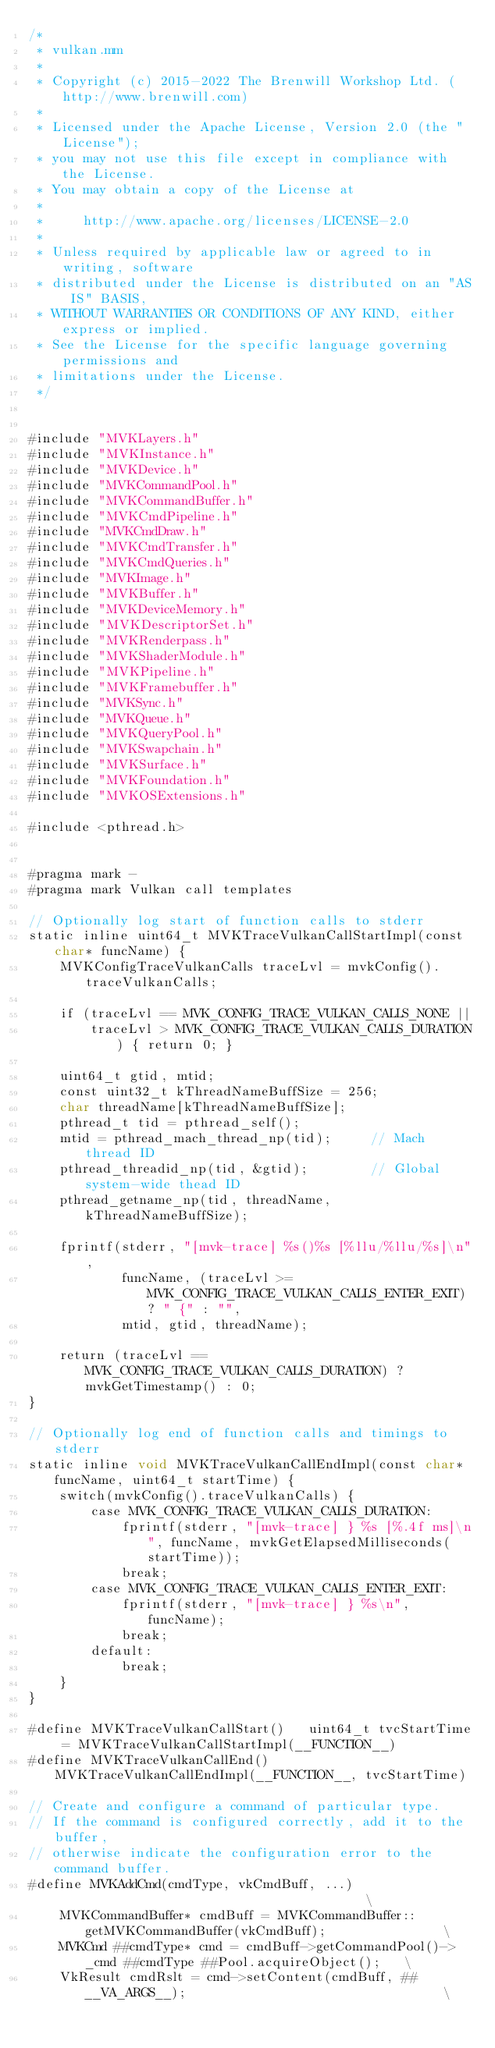<code> <loc_0><loc_0><loc_500><loc_500><_ObjectiveC_>/*
 * vulkan.mm
 *
 * Copyright (c) 2015-2022 The Brenwill Workshop Ltd. (http://www.brenwill.com)
 *
 * Licensed under the Apache License, Version 2.0 (the "License");
 * you may not use this file except in compliance with the License.
 * You may obtain a copy of the License at
 * 
 *     http://www.apache.org/licenses/LICENSE-2.0
 * 
 * Unless required by applicable law or agreed to in writing, software
 * distributed under the License is distributed on an "AS IS" BASIS,
 * WITHOUT WARRANTIES OR CONDITIONS OF ANY KIND, either express or implied.
 * See the License for the specific language governing permissions and
 * limitations under the License.
 */


#include "MVKLayers.h"
#include "MVKInstance.h"
#include "MVKDevice.h"
#include "MVKCommandPool.h"
#include "MVKCommandBuffer.h"
#include "MVKCmdPipeline.h"
#include "MVKCmdDraw.h"
#include "MVKCmdTransfer.h"
#include "MVKCmdQueries.h"
#include "MVKImage.h"
#include "MVKBuffer.h"
#include "MVKDeviceMemory.h"
#include "MVKDescriptorSet.h"
#include "MVKRenderpass.h"
#include "MVKShaderModule.h"
#include "MVKPipeline.h"
#include "MVKFramebuffer.h"
#include "MVKSync.h"
#include "MVKQueue.h"
#include "MVKQueryPool.h"
#include "MVKSwapchain.h"
#include "MVKSurface.h"
#include "MVKFoundation.h"
#include "MVKOSExtensions.h"

#include <pthread.h>


#pragma mark -
#pragma mark Vulkan call templates

// Optionally log start of function calls to stderr
static inline uint64_t MVKTraceVulkanCallStartImpl(const char* funcName) {
	MVKConfigTraceVulkanCalls traceLvl = mvkConfig().traceVulkanCalls;

	if (traceLvl == MVK_CONFIG_TRACE_VULKAN_CALLS_NONE ||
		traceLvl > MVK_CONFIG_TRACE_VULKAN_CALLS_DURATION) { return 0; }

	uint64_t gtid, mtid;
	const uint32_t kThreadNameBuffSize = 256;
	char threadName[kThreadNameBuffSize];
	pthread_t tid = pthread_self();
	mtid = pthread_mach_thread_np(tid);		// Mach thread ID
	pthread_threadid_np(tid, &gtid);		// Global system-wide thead ID
	pthread_getname_np(tid, threadName, kThreadNameBuffSize);

	fprintf(stderr, "[mvk-trace] %s()%s [%llu/%llu/%s]\n",
			funcName, (traceLvl >= MVK_CONFIG_TRACE_VULKAN_CALLS_ENTER_EXIT) ? " {" : "",
			mtid, gtid, threadName);

	return (traceLvl == MVK_CONFIG_TRACE_VULKAN_CALLS_DURATION) ? mvkGetTimestamp() : 0;
}

// Optionally log end of function calls and timings to stderr
static inline void MVKTraceVulkanCallEndImpl(const char* funcName, uint64_t startTime) {
	switch(mvkConfig().traceVulkanCalls) {
		case MVK_CONFIG_TRACE_VULKAN_CALLS_DURATION:
			fprintf(stderr, "[mvk-trace] } %s [%.4f ms]\n", funcName, mvkGetElapsedMilliseconds(startTime));
			break;
		case MVK_CONFIG_TRACE_VULKAN_CALLS_ENTER_EXIT:
			fprintf(stderr, "[mvk-trace] } %s\n", funcName);
			break;
		default:
			break;
	}
}

#define MVKTraceVulkanCallStart()	uint64_t tvcStartTime = MVKTraceVulkanCallStartImpl(__FUNCTION__)
#define MVKTraceVulkanCallEnd()		MVKTraceVulkanCallEndImpl(__FUNCTION__, tvcStartTime)

// Create and configure a command of particular type.
// If the command is configured correctly, add it to the buffer,
// otherwise indicate the configuration error to the command buffer.
#define MVKAddCmd(cmdType, vkCmdBuff, ...)  													\
	MVKCommandBuffer* cmdBuff = MVKCommandBuffer::getMVKCommandBuffer(vkCmdBuff);				\
	MVKCmd ##cmdType* cmd = cmdBuff->getCommandPool()->_cmd ##cmdType ##Pool.acquireObject();	\
	VkResult cmdRslt = cmd->setContent(cmdBuff, ##__VA_ARGS__);									\</code> 